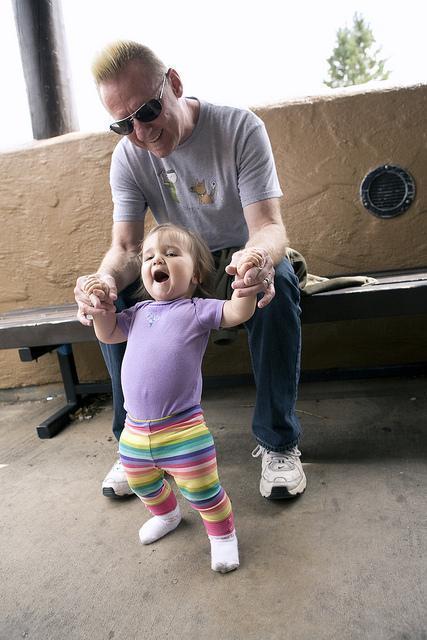How many shoes are seen?
Give a very brief answer. 2. How many benches are there?
Give a very brief answer. 1. How many people are there?
Give a very brief answer. 2. How many black cars are there?
Give a very brief answer. 0. 